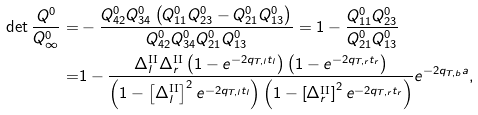<formula> <loc_0><loc_0><loc_500><loc_500>\det \frac { Q ^ { 0 } } { Q _ { \infty } ^ { 0 } } = & - \frac { Q ^ { 0 } _ { 4 2 } Q ^ { 0 } _ { 3 4 } \left ( Q ^ { 0 } _ { 1 1 } Q ^ { 0 } _ { 2 3 } - Q ^ { 0 } _ { 2 1 } Q ^ { 0 } _ { 1 3 } \right ) } { Q ^ { 0 } _ { 4 2 } Q ^ { 0 } _ { 3 4 } Q ^ { 0 } _ { 2 1 } Q ^ { 0 } _ { 1 3 } } = 1 - \frac { Q ^ { 0 } _ { 1 1 } Q ^ { 0 } _ { 2 3 } } { Q ^ { 0 } _ { 2 1 } Q ^ { 0 } _ { 1 3 } } \\ = & 1 - \frac { \Delta _ { l } ^ { \text {II} } \Delta _ { r } ^ { \text {II} } \left ( 1 - e ^ { - 2 q _ { T , l } t _ { l } } \right ) \left ( 1 - e ^ { - 2 q _ { T , r } t _ { r } } \right ) } { \left ( 1 - \left [ \Delta _ { l } ^ { \text {II} } \right ] ^ { 2 } e ^ { - 2 q _ { T , l } t _ { l } } \right ) \left ( 1 - \left [ \Delta _ { r } ^ { \text {II} } \right ] ^ { 2 } e ^ { - 2 q _ { T , r } t _ { r } } \right ) } e ^ { - 2 q _ { T , b } a } ,</formula> 